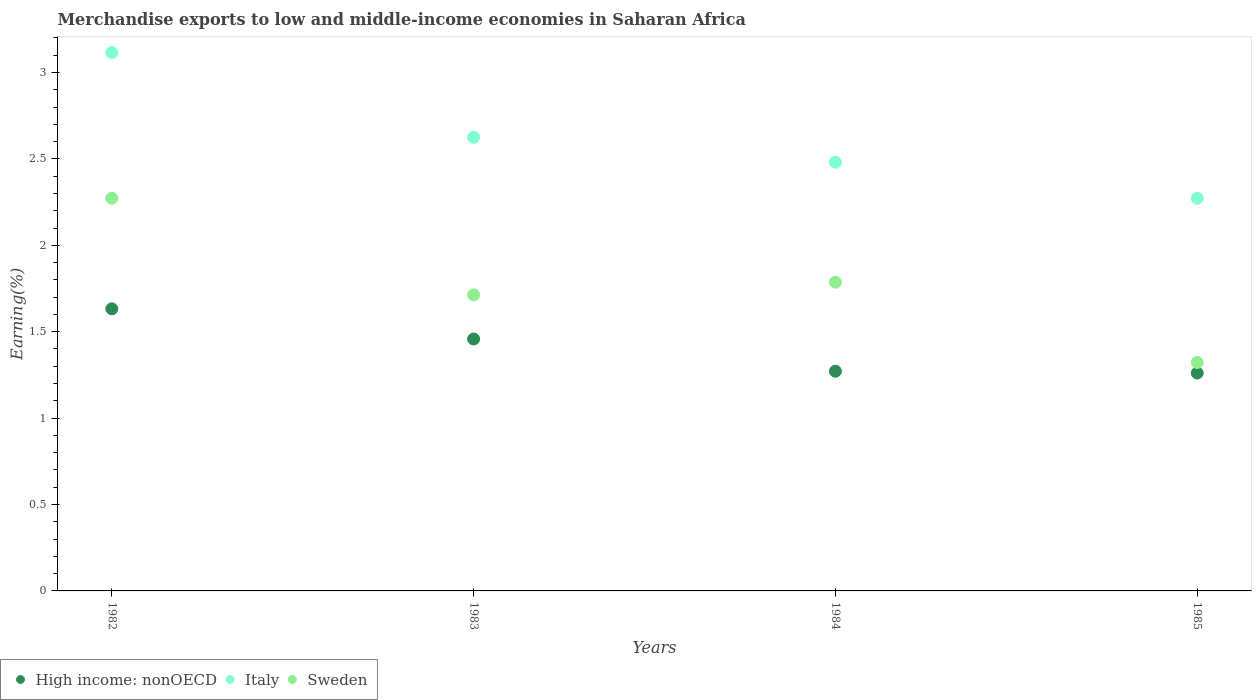Is the number of dotlines equal to the number of legend labels?
Provide a succinct answer. Yes. What is the percentage of amount earned from merchandise exports in High income: nonOECD in 1984?
Your answer should be very brief. 1.27. Across all years, what is the maximum percentage of amount earned from merchandise exports in Italy?
Offer a terse response. 3.12. Across all years, what is the minimum percentage of amount earned from merchandise exports in Italy?
Make the answer very short. 2.27. In which year was the percentage of amount earned from merchandise exports in High income: nonOECD maximum?
Provide a short and direct response. 1982. In which year was the percentage of amount earned from merchandise exports in Italy minimum?
Provide a short and direct response. 1985. What is the total percentage of amount earned from merchandise exports in Italy in the graph?
Your answer should be very brief. 10.49. What is the difference between the percentage of amount earned from merchandise exports in Sweden in 1984 and that in 1985?
Offer a terse response. 0.46. What is the difference between the percentage of amount earned from merchandise exports in High income: nonOECD in 1985 and the percentage of amount earned from merchandise exports in Italy in 1983?
Your answer should be compact. -1.36. What is the average percentage of amount earned from merchandise exports in Sweden per year?
Make the answer very short. 1.77. In the year 1985, what is the difference between the percentage of amount earned from merchandise exports in Sweden and percentage of amount earned from merchandise exports in High income: nonOECD?
Ensure brevity in your answer.  0.06. In how many years, is the percentage of amount earned from merchandise exports in High income: nonOECD greater than 1.5 %?
Your answer should be compact. 1. What is the ratio of the percentage of amount earned from merchandise exports in High income: nonOECD in 1984 to that in 1985?
Your answer should be very brief. 1.01. What is the difference between the highest and the second highest percentage of amount earned from merchandise exports in High income: nonOECD?
Make the answer very short. 0.17. What is the difference between the highest and the lowest percentage of amount earned from merchandise exports in High income: nonOECD?
Offer a terse response. 0.37. Is the sum of the percentage of amount earned from merchandise exports in High income: nonOECD in 1982 and 1985 greater than the maximum percentage of amount earned from merchandise exports in Italy across all years?
Ensure brevity in your answer.  No. Is it the case that in every year, the sum of the percentage of amount earned from merchandise exports in Italy and percentage of amount earned from merchandise exports in High income: nonOECD  is greater than the percentage of amount earned from merchandise exports in Sweden?
Ensure brevity in your answer.  Yes. Does the percentage of amount earned from merchandise exports in High income: nonOECD monotonically increase over the years?
Ensure brevity in your answer.  No. Is the percentage of amount earned from merchandise exports in Sweden strictly less than the percentage of amount earned from merchandise exports in Italy over the years?
Provide a succinct answer. Yes. How many years are there in the graph?
Keep it short and to the point. 4. Are the values on the major ticks of Y-axis written in scientific E-notation?
Make the answer very short. No. Does the graph contain any zero values?
Your answer should be very brief. No. Does the graph contain grids?
Your answer should be very brief. No. Where does the legend appear in the graph?
Give a very brief answer. Bottom left. How many legend labels are there?
Provide a succinct answer. 3. What is the title of the graph?
Your answer should be very brief. Merchandise exports to low and middle-income economies in Saharan Africa. Does "Portugal" appear as one of the legend labels in the graph?
Offer a terse response. No. What is the label or title of the X-axis?
Your answer should be very brief. Years. What is the label or title of the Y-axis?
Your response must be concise. Earning(%). What is the Earning(%) of High income: nonOECD in 1982?
Make the answer very short. 1.63. What is the Earning(%) in Italy in 1982?
Your response must be concise. 3.12. What is the Earning(%) in Sweden in 1982?
Provide a succinct answer. 2.27. What is the Earning(%) of High income: nonOECD in 1983?
Make the answer very short. 1.46. What is the Earning(%) of Italy in 1983?
Offer a very short reply. 2.62. What is the Earning(%) in Sweden in 1983?
Ensure brevity in your answer.  1.71. What is the Earning(%) of High income: nonOECD in 1984?
Give a very brief answer. 1.27. What is the Earning(%) in Italy in 1984?
Give a very brief answer. 2.48. What is the Earning(%) of Sweden in 1984?
Your answer should be very brief. 1.79. What is the Earning(%) in High income: nonOECD in 1985?
Offer a terse response. 1.26. What is the Earning(%) of Italy in 1985?
Offer a terse response. 2.27. What is the Earning(%) of Sweden in 1985?
Your answer should be compact. 1.32. Across all years, what is the maximum Earning(%) of High income: nonOECD?
Keep it short and to the point. 1.63. Across all years, what is the maximum Earning(%) in Italy?
Offer a terse response. 3.12. Across all years, what is the maximum Earning(%) in Sweden?
Keep it short and to the point. 2.27. Across all years, what is the minimum Earning(%) of High income: nonOECD?
Provide a short and direct response. 1.26. Across all years, what is the minimum Earning(%) in Italy?
Your answer should be compact. 2.27. Across all years, what is the minimum Earning(%) in Sweden?
Your answer should be very brief. 1.32. What is the total Earning(%) in High income: nonOECD in the graph?
Ensure brevity in your answer.  5.62. What is the total Earning(%) in Italy in the graph?
Offer a terse response. 10.49. What is the total Earning(%) of Sweden in the graph?
Provide a succinct answer. 7.09. What is the difference between the Earning(%) in High income: nonOECD in 1982 and that in 1983?
Your response must be concise. 0.17. What is the difference between the Earning(%) of Italy in 1982 and that in 1983?
Your answer should be very brief. 0.49. What is the difference between the Earning(%) of Sweden in 1982 and that in 1983?
Offer a terse response. 0.56. What is the difference between the Earning(%) of High income: nonOECD in 1982 and that in 1984?
Offer a very short reply. 0.36. What is the difference between the Earning(%) of Italy in 1982 and that in 1984?
Provide a succinct answer. 0.63. What is the difference between the Earning(%) of Sweden in 1982 and that in 1984?
Offer a very short reply. 0.49. What is the difference between the Earning(%) in High income: nonOECD in 1982 and that in 1985?
Your answer should be very brief. 0.37. What is the difference between the Earning(%) in Italy in 1982 and that in 1985?
Make the answer very short. 0.84. What is the difference between the Earning(%) of Sweden in 1982 and that in 1985?
Make the answer very short. 0.95. What is the difference between the Earning(%) of High income: nonOECD in 1983 and that in 1984?
Give a very brief answer. 0.19. What is the difference between the Earning(%) of Italy in 1983 and that in 1984?
Offer a terse response. 0.14. What is the difference between the Earning(%) of Sweden in 1983 and that in 1984?
Provide a short and direct response. -0.07. What is the difference between the Earning(%) in High income: nonOECD in 1983 and that in 1985?
Provide a succinct answer. 0.2. What is the difference between the Earning(%) in Italy in 1983 and that in 1985?
Offer a very short reply. 0.35. What is the difference between the Earning(%) of Sweden in 1983 and that in 1985?
Offer a terse response. 0.39. What is the difference between the Earning(%) of High income: nonOECD in 1984 and that in 1985?
Offer a very short reply. 0.01. What is the difference between the Earning(%) in Italy in 1984 and that in 1985?
Keep it short and to the point. 0.21. What is the difference between the Earning(%) of Sweden in 1984 and that in 1985?
Provide a short and direct response. 0.46. What is the difference between the Earning(%) of High income: nonOECD in 1982 and the Earning(%) of Italy in 1983?
Ensure brevity in your answer.  -0.99. What is the difference between the Earning(%) in High income: nonOECD in 1982 and the Earning(%) in Sweden in 1983?
Provide a succinct answer. -0.08. What is the difference between the Earning(%) in Italy in 1982 and the Earning(%) in Sweden in 1983?
Give a very brief answer. 1.4. What is the difference between the Earning(%) of High income: nonOECD in 1982 and the Earning(%) of Italy in 1984?
Offer a very short reply. -0.85. What is the difference between the Earning(%) of High income: nonOECD in 1982 and the Earning(%) of Sweden in 1984?
Offer a very short reply. -0.15. What is the difference between the Earning(%) of Italy in 1982 and the Earning(%) of Sweden in 1984?
Offer a very short reply. 1.33. What is the difference between the Earning(%) in High income: nonOECD in 1982 and the Earning(%) in Italy in 1985?
Your response must be concise. -0.64. What is the difference between the Earning(%) in High income: nonOECD in 1982 and the Earning(%) in Sweden in 1985?
Make the answer very short. 0.31. What is the difference between the Earning(%) in Italy in 1982 and the Earning(%) in Sweden in 1985?
Your answer should be very brief. 1.79. What is the difference between the Earning(%) of High income: nonOECD in 1983 and the Earning(%) of Italy in 1984?
Offer a terse response. -1.02. What is the difference between the Earning(%) of High income: nonOECD in 1983 and the Earning(%) of Sweden in 1984?
Give a very brief answer. -0.33. What is the difference between the Earning(%) in Italy in 1983 and the Earning(%) in Sweden in 1984?
Your answer should be compact. 0.84. What is the difference between the Earning(%) in High income: nonOECD in 1983 and the Earning(%) in Italy in 1985?
Make the answer very short. -0.81. What is the difference between the Earning(%) of High income: nonOECD in 1983 and the Earning(%) of Sweden in 1985?
Ensure brevity in your answer.  0.14. What is the difference between the Earning(%) of Italy in 1983 and the Earning(%) of Sweden in 1985?
Ensure brevity in your answer.  1.3. What is the difference between the Earning(%) of High income: nonOECD in 1984 and the Earning(%) of Italy in 1985?
Your response must be concise. -1. What is the difference between the Earning(%) of High income: nonOECD in 1984 and the Earning(%) of Sweden in 1985?
Give a very brief answer. -0.05. What is the difference between the Earning(%) in Italy in 1984 and the Earning(%) in Sweden in 1985?
Provide a short and direct response. 1.16. What is the average Earning(%) of High income: nonOECD per year?
Keep it short and to the point. 1.41. What is the average Earning(%) in Italy per year?
Your response must be concise. 2.62. What is the average Earning(%) in Sweden per year?
Ensure brevity in your answer.  1.77. In the year 1982, what is the difference between the Earning(%) of High income: nonOECD and Earning(%) of Italy?
Your response must be concise. -1.48. In the year 1982, what is the difference between the Earning(%) in High income: nonOECD and Earning(%) in Sweden?
Your response must be concise. -0.64. In the year 1982, what is the difference between the Earning(%) of Italy and Earning(%) of Sweden?
Offer a terse response. 0.84. In the year 1983, what is the difference between the Earning(%) of High income: nonOECD and Earning(%) of Italy?
Keep it short and to the point. -1.17. In the year 1983, what is the difference between the Earning(%) in High income: nonOECD and Earning(%) in Sweden?
Your answer should be very brief. -0.26. In the year 1983, what is the difference between the Earning(%) of Italy and Earning(%) of Sweden?
Provide a short and direct response. 0.91. In the year 1984, what is the difference between the Earning(%) in High income: nonOECD and Earning(%) in Italy?
Offer a very short reply. -1.21. In the year 1984, what is the difference between the Earning(%) of High income: nonOECD and Earning(%) of Sweden?
Ensure brevity in your answer.  -0.52. In the year 1984, what is the difference between the Earning(%) of Italy and Earning(%) of Sweden?
Your answer should be compact. 0.69. In the year 1985, what is the difference between the Earning(%) of High income: nonOECD and Earning(%) of Italy?
Provide a short and direct response. -1.01. In the year 1985, what is the difference between the Earning(%) of High income: nonOECD and Earning(%) of Sweden?
Provide a succinct answer. -0.06. In the year 1985, what is the difference between the Earning(%) in Italy and Earning(%) in Sweden?
Provide a short and direct response. 0.95. What is the ratio of the Earning(%) of High income: nonOECD in 1982 to that in 1983?
Give a very brief answer. 1.12. What is the ratio of the Earning(%) in Italy in 1982 to that in 1983?
Ensure brevity in your answer.  1.19. What is the ratio of the Earning(%) in Sweden in 1982 to that in 1983?
Your answer should be compact. 1.33. What is the ratio of the Earning(%) in High income: nonOECD in 1982 to that in 1984?
Offer a very short reply. 1.28. What is the ratio of the Earning(%) in Italy in 1982 to that in 1984?
Your response must be concise. 1.26. What is the ratio of the Earning(%) in Sweden in 1982 to that in 1984?
Provide a succinct answer. 1.27. What is the ratio of the Earning(%) of High income: nonOECD in 1982 to that in 1985?
Ensure brevity in your answer.  1.29. What is the ratio of the Earning(%) in Italy in 1982 to that in 1985?
Ensure brevity in your answer.  1.37. What is the ratio of the Earning(%) of Sweden in 1982 to that in 1985?
Make the answer very short. 1.72. What is the ratio of the Earning(%) of High income: nonOECD in 1983 to that in 1984?
Provide a succinct answer. 1.15. What is the ratio of the Earning(%) of Italy in 1983 to that in 1984?
Give a very brief answer. 1.06. What is the ratio of the Earning(%) in Sweden in 1983 to that in 1984?
Offer a terse response. 0.96. What is the ratio of the Earning(%) in High income: nonOECD in 1983 to that in 1985?
Your answer should be compact. 1.16. What is the ratio of the Earning(%) of Italy in 1983 to that in 1985?
Your response must be concise. 1.16. What is the ratio of the Earning(%) of Sweden in 1983 to that in 1985?
Your response must be concise. 1.3. What is the ratio of the Earning(%) in High income: nonOECD in 1984 to that in 1985?
Your answer should be very brief. 1.01. What is the ratio of the Earning(%) of Italy in 1984 to that in 1985?
Provide a short and direct response. 1.09. What is the ratio of the Earning(%) in Sweden in 1984 to that in 1985?
Keep it short and to the point. 1.35. What is the difference between the highest and the second highest Earning(%) of High income: nonOECD?
Provide a short and direct response. 0.17. What is the difference between the highest and the second highest Earning(%) in Italy?
Offer a terse response. 0.49. What is the difference between the highest and the second highest Earning(%) in Sweden?
Provide a succinct answer. 0.49. What is the difference between the highest and the lowest Earning(%) of High income: nonOECD?
Your response must be concise. 0.37. What is the difference between the highest and the lowest Earning(%) of Italy?
Provide a short and direct response. 0.84. What is the difference between the highest and the lowest Earning(%) of Sweden?
Give a very brief answer. 0.95. 